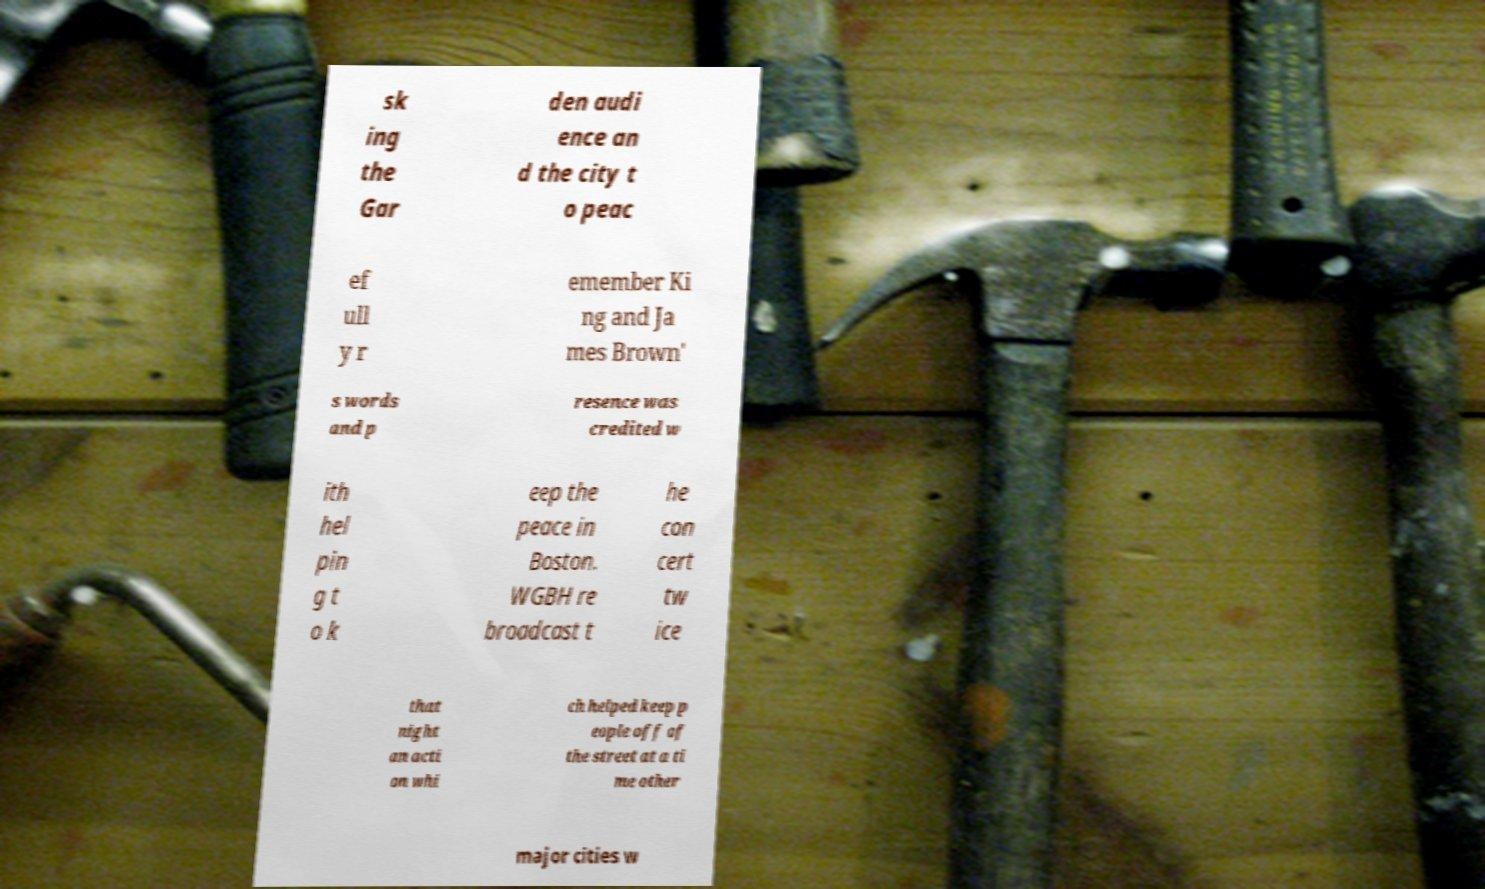Can you accurately transcribe the text from the provided image for me? sk ing the Gar den audi ence an d the city t o peac ef ull y r emember Ki ng and Ja mes Brown' s words and p resence was credited w ith hel pin g t o k eep the peace in Boston. WGBH re broadcast t he con cert tw ice that night an acti on whi ch helped keep p eople off of the street at a ti me other major cities w 